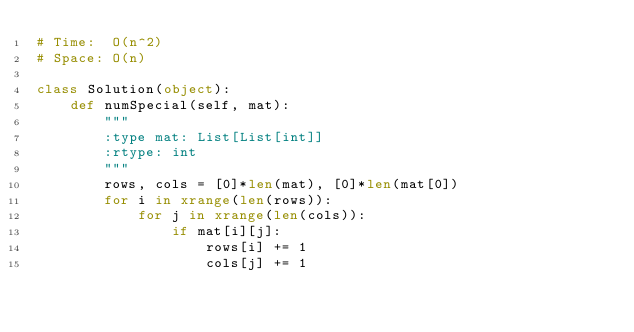Convert code to text. <code><loc_0><loc_0><loc_500><loc_500><_Python_># Time:  O(n^2)
# Space: O(n)

class Solution(object):
    def numSpecial(self, mat):
        """
        :type mat: List[List[int]]
        :rtype: int
        """
        rows, cols = [0]*len(mat), [0]*len(mat[0])
        for i in xrange(len(rows)):
            for j in xrange(len(cols)):
                if mat[i][j]:
                    rows[i] += 1
                    cols[j] += 1</code> 